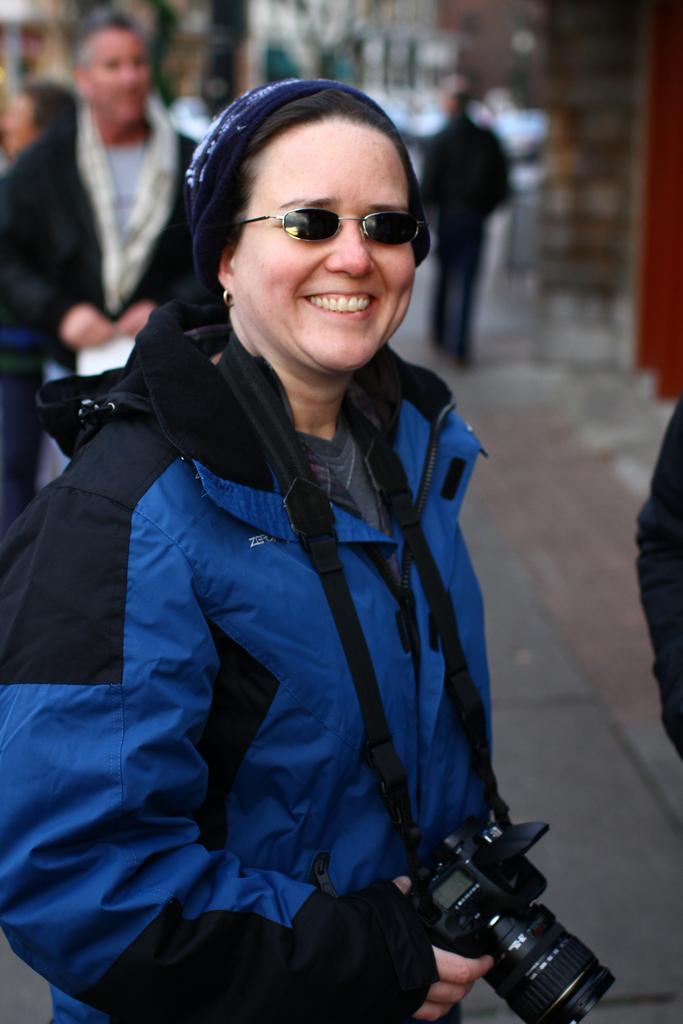Describe this image in one or two sentences. In this picture i could see a woman in blue jacket wearing a camera in her neck. She is even having googles. In the background i could see a person walking on the street. 